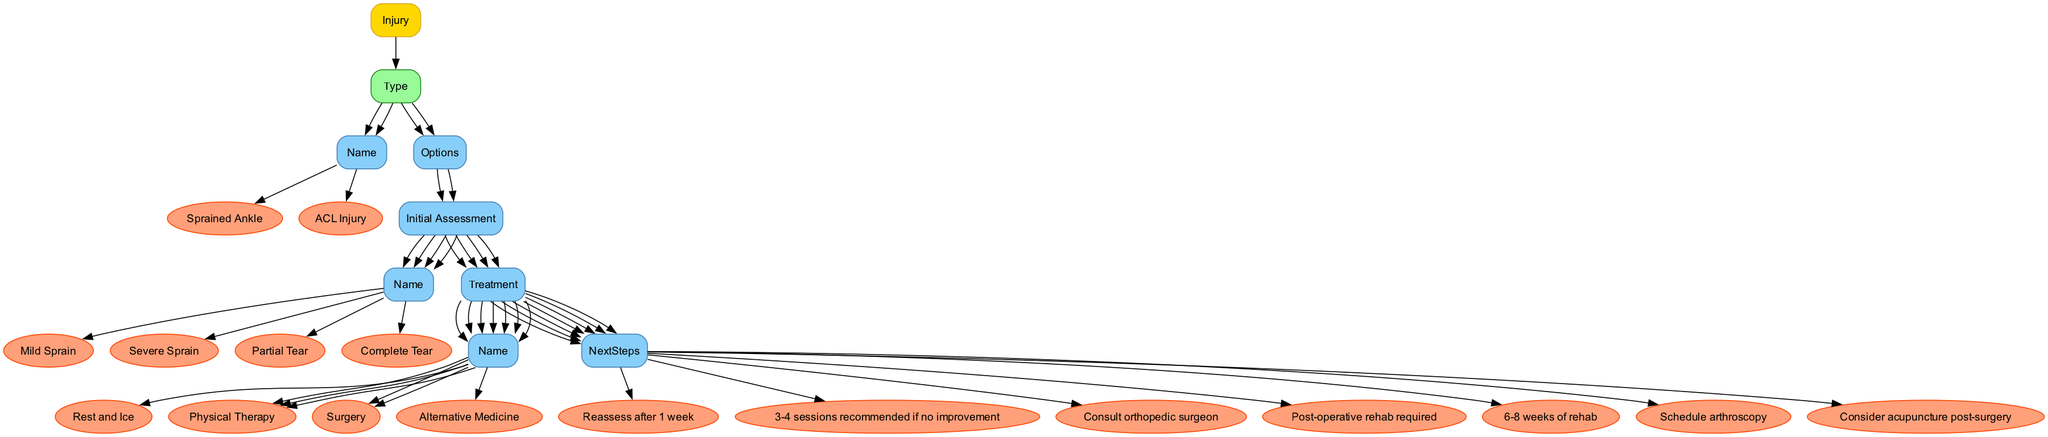What are the two types of injuries listed in the diagram? The diagram specifies two types of injuries: "Sprained Ankle" and "ACL Injury." These are the main categories represented in the tree structure of the decision points for treatment options.
Answer: Sprained Ankle, ACL Injury What treatment is recommended for a mild sprain? According to the diagram, a mild sprain is recommended to be treated with "Rest and Ice." This is directly linked to the options provided for handling a sprained ankle under the mild sprain assessment.
Answer: Rest and Ice How many treatment options are available for a complete tear of the ACL? The diagram shows two treatment options available for a complete tear of the ACL: "Surgery" and "Alternative Medicine." Each option branches out from the complete tear assessment node.
Answer: 2 What is the next step after surgery for a severe sprain? The diagram clearly states that after surgery for a severe sprain, the next step is to "Consult orthopedic surgeon." This indicates the following course of action after choosing surgery.
Answer: Consult orthopedic surgeon What is the next recommended step after 3-4 sessions of physical therapy for a mild sprain? The diagram notes that if no improvement is seen after 3-4 sessions of physical therapy for a mild sprain, the next step is to reassess the condition. This connects the treatment to the evaluation of its effectiveness.
Answer: Reassess after 1 week What is the last treatment option available for a complete tear of the ACL, according to the diagram? The diagram indicates that after the surgical option, "Alternative Medicine" is the last treatment option available for a complete tear of the ACL, specifically noting acupuncture as a consideration.
Answer: Alternative Medicine Which injury option leads directly to physical therapy without surgery? The "Partial Tear" under the ACL Injury option leads directly to "Physical Therapy" without the need for surgery, indicating a non-invasive treatment approach for that type of injury.
Answer: Partial Tear What is the required duration of physical therapy for a partial ACL tear? The diagram mentions that "6-8 weeks of rehab" is the required duration for physical therapy following a partial ACL tear, indicating a specific timeframe for recovery in this case.
Answer: 6-8 weeks of rehab 